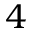Convert formula to latex. <formula><loc_0><loc_0><loc_500><loc_500>4</formula> 